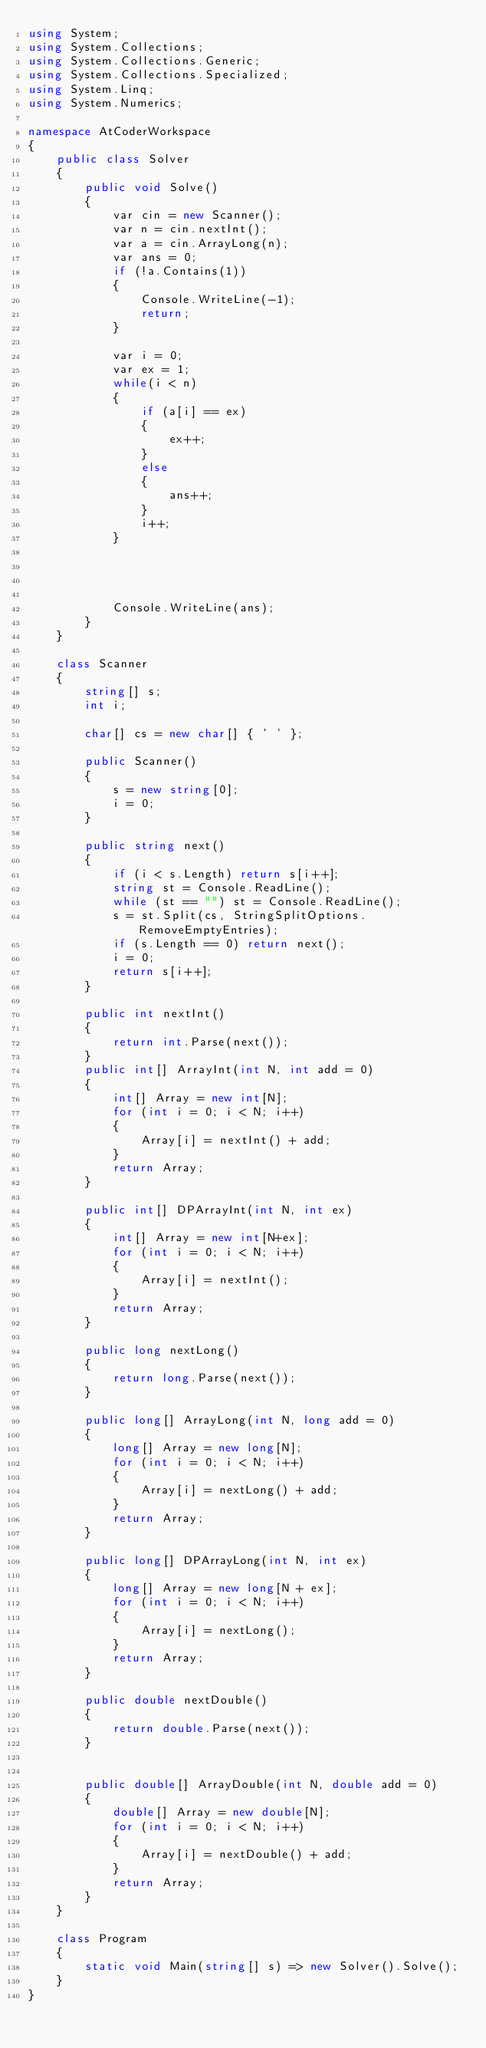<code> <loc_0><loc_0><loc_500><loc_500><_C#_>using System;
using System.Collections;
using System.Collections.Generic;
using System.Collections.Specialized;
using System.Linq;
using System.Numerics;

namespace AtCoderWorkspace
{
    public class Solver
    {
        public void Solve()
        {
            var cin = new Scanner();
            var n = cin.nextInt();
            var a = cin.ArrayLong(n);
            var ans = 0;
            if (!a.Contains(1))
            {
                Console.WriteLine(-1);
                return;
            }

            var i = 0;
            var ex = 1;
            while(i < n)
            {
                if (a[i] == ex)
                {
                    ex++;
                }
                else
                {
                    ans++;
                }
                i++;
            }
            

           

            Console.WriteLine(ans);
        }
    }

    class Scanner
    {
        string[] s;
        int i;

        char[] cs = new char[] { ' ' };

        public Scanner()
        {
            s = new string[0];
            i = 0;
        }

        public string next()
        {
            if (i < s.Length) return s[i++];
            string st = Console.ReadLine();
            while (st == "") st = Console.ReadLine();
            s = st.Split(cs, StringSplitOptions.RemoveEmptyEntries);
            if (s.Length == 0) return next();
            i = 0;
            return s[i++];
        }

        public int nextInt()
        {
            return int.Parse(next());
        }
        public int[] ArrayInt(int N, int add = 0)
        {
            int[] Array = new int[N];
            for (int i = 0; i < N; i++)
            {
                Array[i] = nextInt() + add;
            }
            return Array;
        }

        public int[] DPArrayInt(int N, int ex)
        {
            int[] Array = new int[N+ex];
            for (int i = 0; i < N; i++)
            {
                Array[i] = nextInt();
            }
            return Array;
        }

        public long nextLong()
        {
            return long.Parse(next());
        }

        public long[] ArrayLong(int N, long add = 0)
        {
            long[] Array = new long[N];
            for (int i = 0; i < N; i++)
            {
                Array[i] = nextLong() + add;
            }
            return Array;
        }

        public long[] DPArrayLong(int N, int ex)
        {
            long[] Array = new long[N + ex];
            for (int i = 0; i < N; i++)
            {
                Array[i] = nextLong();
            }
            return Array;
        }

        public double nextDouble()
        {
            return double.Parse(next());
        }


        public double[] ArrayDouble(int N, double add = 0)
        {
            double[] Array = new double[N];
            for (int i = 0; i < N; i++)
            {
                Array[i] = nextDouble() + add;
            }
            return Array;
        }
    }   

    class Program
    {
        static void Main(string[] s) => new Solver().Solve();
    }
}
</code> 